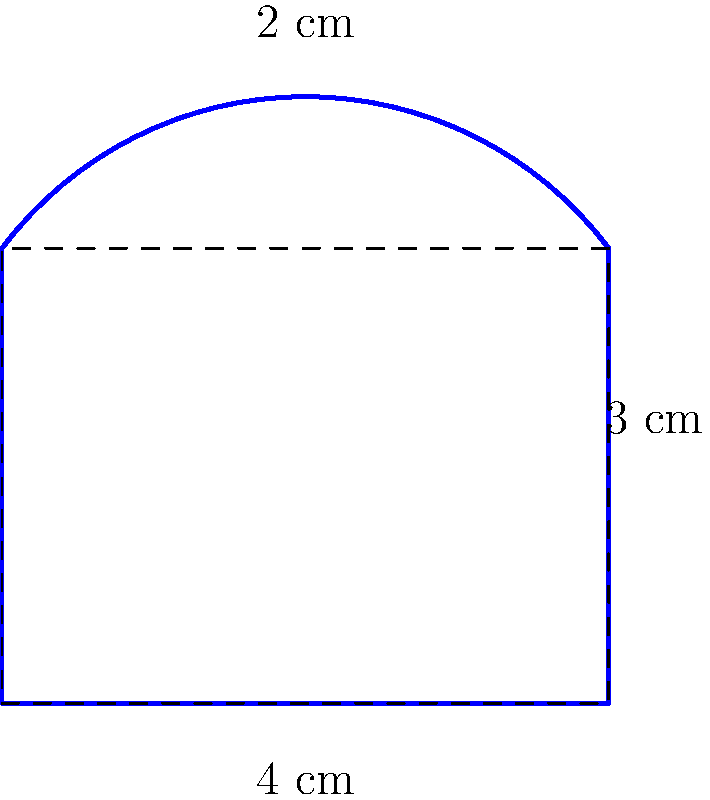For your upcoming fan meet, you're designing a heart-shaped fan sign. The base is a rectangle measuring 4 cm wide and 3 cm tall, with a semicircle on top that has a height of 1 cm. What is the perimeter of this fan sign? Let's break this down step-by-step:

1) The base rectangle:
   - Width = 4 cm
   - Height = 3 cm

2) The semicircle:
   - Height = 1 cm
   - Radius = 2 cm (half the width of the rectangle)

3) Perimeter calculation:
   a) Rectangle sides:
      - Bottom: 4 cm
      - Left side: 3 cm
      - Right side: 3 cm
      
   b) Semicircle:
      - Circumference of a full circle = $2\pi r$
      - For a semicircle, we need half of this: $\pi r$
      - $r = 2$ cm, so the arc length is $2\pi$ cm

4) Total perimeter:
   $$ 4 + 3 + 3 + 2\pi = 10 + 2\pi \text{ cm} $$

5) If we need a numeric value, we can calculate:
   $$ 10 + 2\pi \approx 16.28 \text{ cm} $$
Answer: $10 + 2\pi$ cm (or approximately 16.28 cm) 